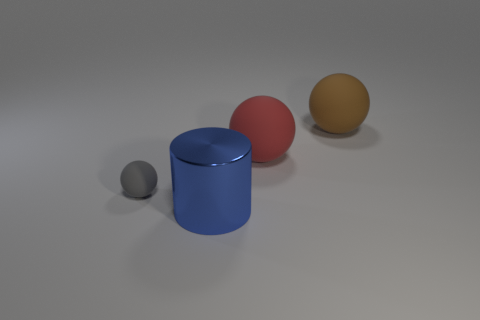Subtract all large matte balls. How many balls are left? 1 Add 4 tiny purple metal cylinders. How many objects exist? 8 Subtract all yellow balls. Subtract all green cubes. How many balls are left? 3 Subtract all balls. How many objects are left? 1 Add 1 brown rubber spheres. How many brown rubber spheres are left? 2 Add 1 big red objects. How many big red objects exist? 2 Subtract 0 purple spheres. How many objects are left? 4 Subtract all red rubber spheres. Subtract all shiny things. How many objects are left? 2 